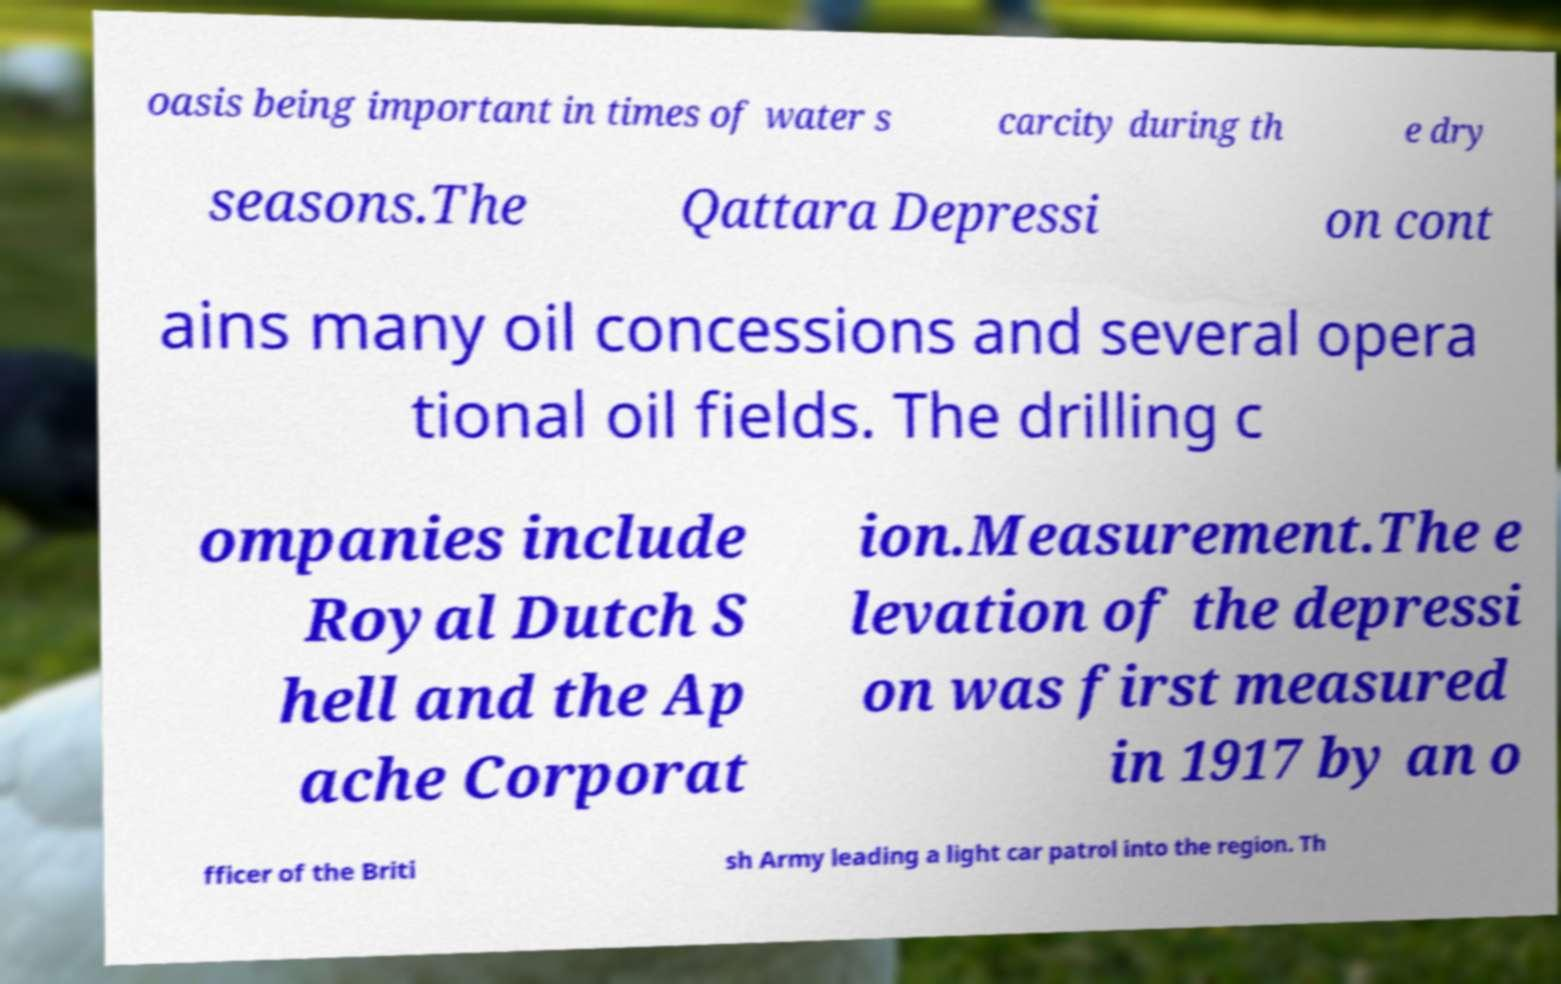Could you extract and type out the text from this image? oasis being important in times of water s carcity during th e dry seasons.The Qattara Depressi on cont ains many oil concessions and several opera tional oil fields. The drilling c ompanies include Royal Dutch S hell and the Ap ache Corporat ion.Measurement.The e levation of the depressi on was first measured in 1917 by an o fficer of the Briti sh Army leading a light car patrol into the region. Th 